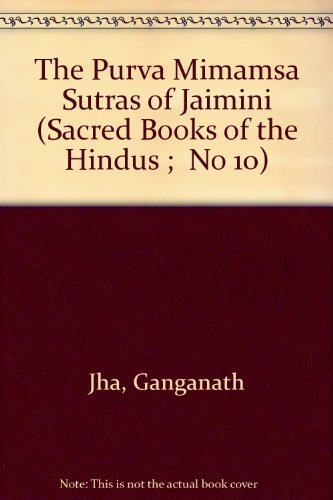Who wrote this book? The author of 'The Purva Mimamsa Sutras of Jaimini' is Ganganath Jha, a respected translator and scholar in the field of Indian philosophy. 